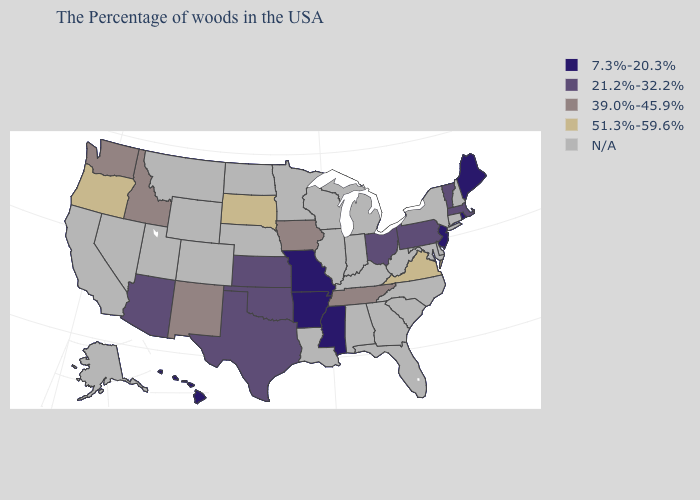What is the highest value in the West ?
Write a very short answer. 51.3%-59.6%. Name the states that have a value in the range 21.2%-32.2%?
Keep it brief. Massachusetts, Vermont, Pennsylvania, Ohio, Kansas, Oklahoma, Texas, Arizona. Which states have the highest value in the USA?
Answer briefly. Virginia, South Dakota, Oregon. Name the states that have a value in the range 21.2%-32.2%?
Keep it brief. Massachusetts, Vermont, Pennsylvania, Ohio, Kansas, Oklahoma, Texas, Arizona. What is the highest value in the USA?
Keep it brief. 51.3%-59.6%. What is the value of Idaho?
Concise answer only. 39.0%-45.9%. Which states hav the highest value in the South?
Keep it brief. Virginia. Does the map have missing data?
Keep it brief. Yes. What is the value of Wisconsin?
Keep it brief. N/A. What is the value of Hawaii?
Write a very short answer. 7.3%-20.3%. Name the states that have a value in the range 39.0%-45.9%?
Write a very short answer. Tennessee, Iowa, New Mexico, Idaho, Washington. Is the legend a continuous bar?
Give a very brief answer. No. Name the states that have a value in the range N/A?
Concise answer only. New Hampshire, Connecticut, New York, Delaware, Maryland, North Carolina, South Carolina, West Virginia, Florida, Georgia, Michigan, Kentucky, Indiana, Alabama, Wisconsin, Illinois, Louisiana, Minnesota, Nebraska, North Dakota, Wyoming, Colorado, Utah, Montana, Nevada, California, Alaska. How many symbols are there in the legend?
Write a very short answer. 5. Name the states that have a value in the range 39.0%-45.9%?
Concise answer only. Tennessee, Iowa, New Mexico, Idaho, Washington. 